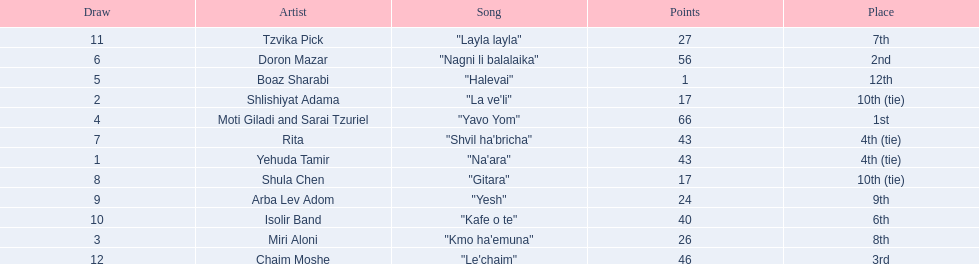Did the song "gitara" or "yesh" earn more points? "Yesh". 